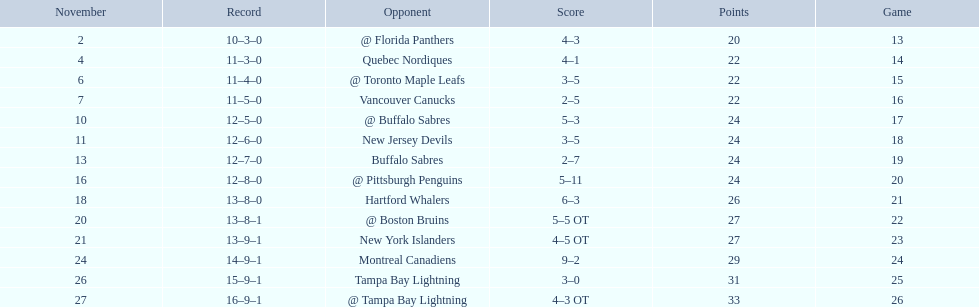What were the scores? @ Florida Panthers, 4–3, Quebec Nordiques, 4–1, @ Toronto Maple Leafs, 3–5, Vancouver Canucks, 2–5, @ Buffalo Sabres, 5–3, New Jersey Devils, 3–5, Buffalo Sabres, 2–7, @ Pittsburgh Penguins, 5–11, Hartford Whalers, 6–3, @ Boston Bruins, 5–5 OT, New York Islanders, 4–5 OT, Montreal Canadiens, 9–2, Tampa Bay Lightning, 3–0, @ Tampa Bay Lightning, 4–3 OT. What score was the closest? New York Islanders, 4–5 OT. What team had that score? New York Islanders. 